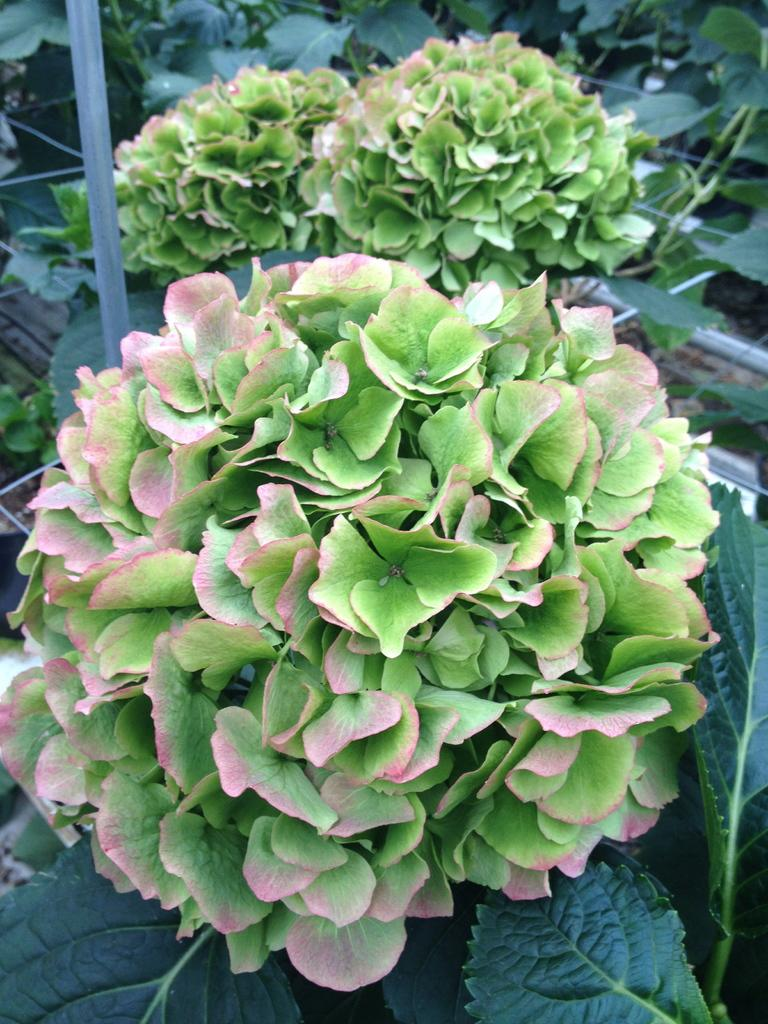What type of living organisms can be seen in the image? Plants and flowers are visible in the image. What structure can be seen in the image? There is a fence in the image. What type of comfort can be provided by the flowers in the image? The image does not convey any information about comfort or emotions; it simply shows plants, flowers, and a fence. 